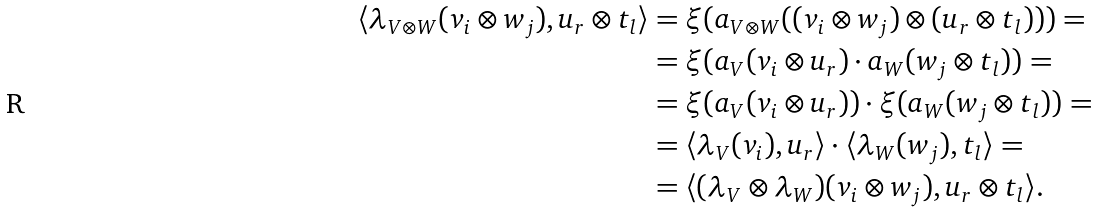<formula> <loc_0><loc_0><loc_500><loc_500>\langle \lambda _ { V \otimes W } ( v _ { i } \otimes w _ { j } ) , u _ { r } \otimes t _ { l } \rangle & = \xi ( a _ { V \otimes W } ( ( v _ { i } \otimes w _ { j } ) \otimes ( u _ { r } \otimes t _ { l } ) ) ) = \\ & = \xi ( a _ { V } ( v _ { i } \otimes u _ { r } ) \cdot a _ { W } ( w _ { j } \otimes t _ { l } ) ) = \\ & = \xi ( a _ { V } ( v _ { i } \otimes u _ { r } ) ) \cdot \xi ( a _ { W } ( w _ { j } \otimes t _ { l } ) ) = \\ & = \langle \lambda _ { V } ( v _ { i } ) , u _ { r } \rangle \cdot \langle \lambda _ { W } ( w _ { j } ) , t _ { l } \rangle = \\ & = \langle ( \lambda _ { V } \otimes \lambda _ { W } ) ( v _ { i } \otimes w _ { j } ) , u _ { r } \otimes t _ { l } \rangle .</formula> 